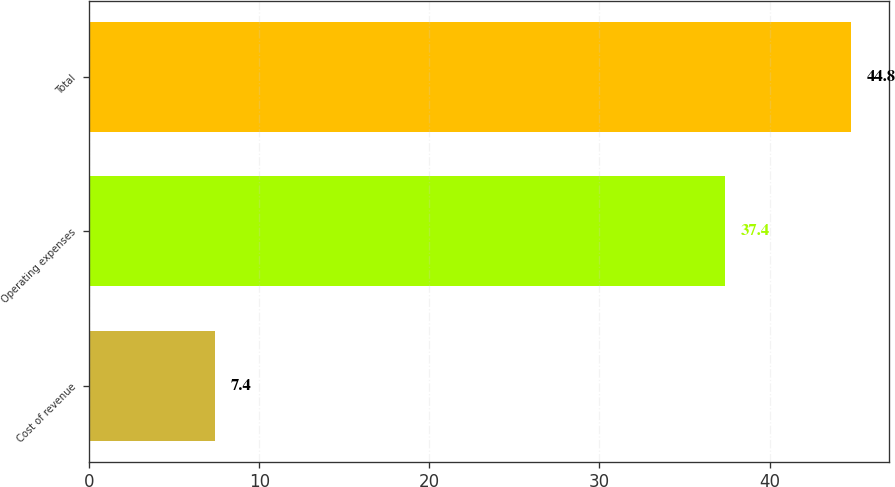Convert chart to OTSL. <chart><loc_0><loc_0><loc_500><loc_500><bar_chart><fcel>Cost of revenue<fcel>Operating expenses<fcel>Total<nl><fcel>7.4<fcel>37.4<fcel>44.8<nl></chart> 